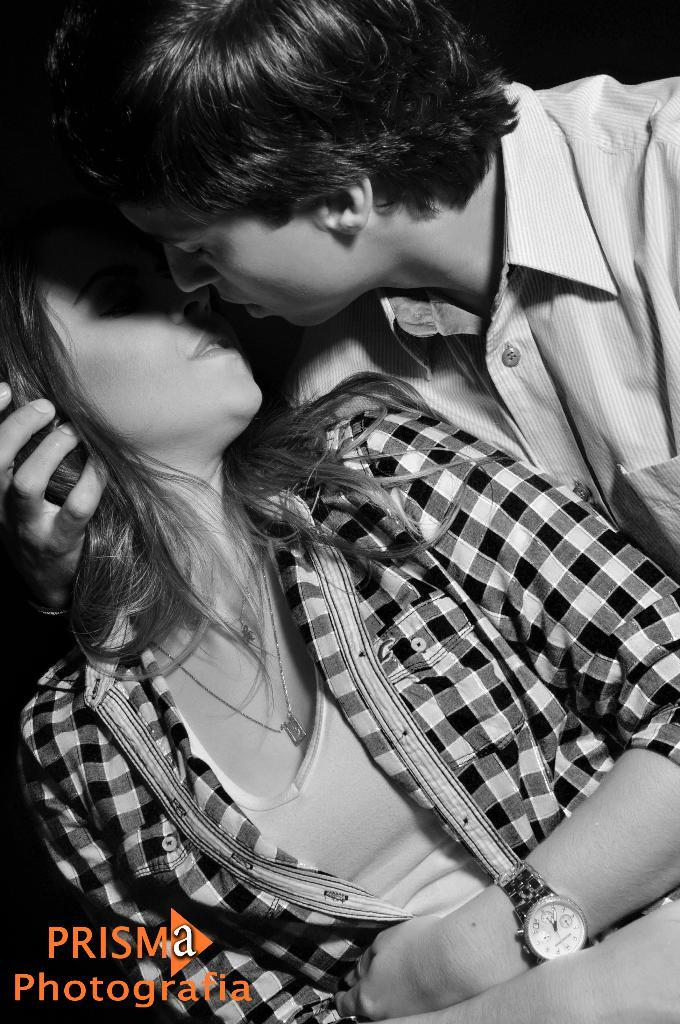What is the color scheme of the image? The image is black and white. Can you describe the subjects in the image? There are a few people in the image. Where is the text located in the image? The text is on the bottom left corner of the image. What type of pail is being used by the people in the image? There is no pail visible in the image. How does the taste of the image compare to other images? The image is black and white, so it does not have a taste. 